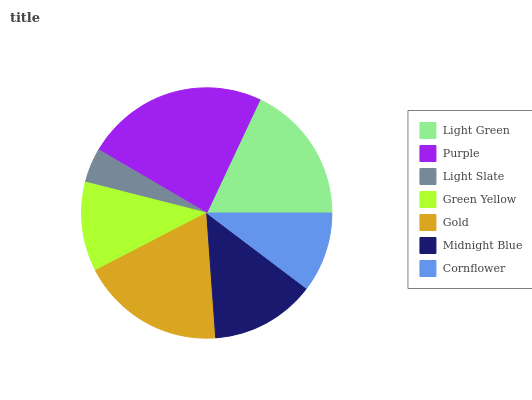Is Light Slate the minimum?
Answer yes or no. Yes. Is Purple the maximum?
Answer yes or no. Yes. Is Purple the minimum?
Answer yes or no. No. Is Light Slate the maximum?
Answer yes or no. No. Is Purple greater than Light Slate?
Answer yes or no. Yes. Is Light Slate less than Purple?
Answer yes or no. Yes. Is Light Slate greater than Purple?
Answer yes or no. No. Is Purple less than Light Slate?
Answer yes or no. No. Is Midnight Blue the high median?
Answer yes or no. Yes. Is Midnight Blue the low median?
Answer yes or no. Yes. Is Green Yellow the high median?
Answer yes or no. No. Is Gold the low median?
Answer yes or no. No. 